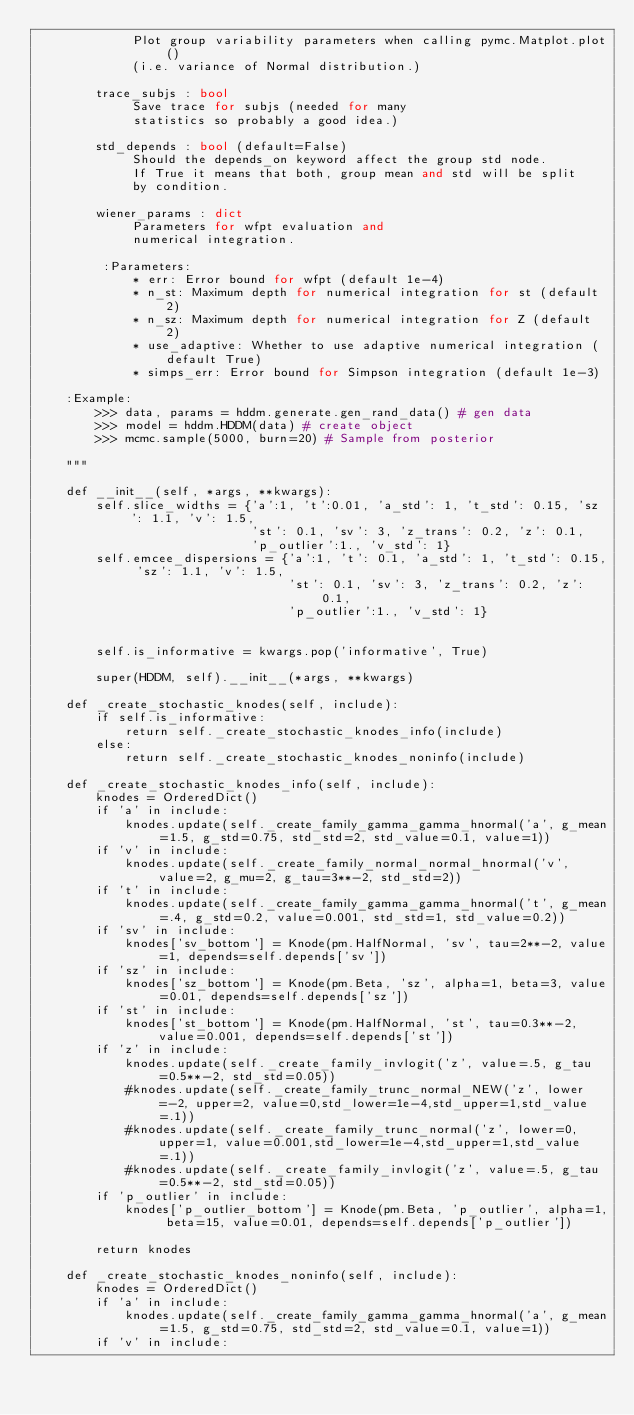<code> <loc_0><loc_0><loc_500><loc_500><_Python_>             Plot group variability parameters when calling pymc.Matplot.plot()
             (i.e. variance of Normal distribution.)

        trace_subjs : bool
             Save trace for subjs (needed for many
             statistics so probably a good idea.)

        std_depends : bool (default=False)
             Should the depends_on keyword affect the group std node.
             If True it means that both, group mean and std will be split
             by condition.

        wiener_params : dict
             Parameters for wfpt evaluation and
             numerical integration.

         :Parameters:
             * err: Error bound for wfpt (default 1e-4)
             * n_st: Maximum depth for numerical integration for st (default 2)
             * n_sz: Maximum depth for numerical integration for Z (default 2)
             * use_adaptive: Whether to use adaptive numerical integration (default True)
             * simps_err: Error bound for Simpson integration (default 1e-3)

    :Example:
        >>> data, params = hddm.generate.gen_rand_data() # gen data
        >>> model = hddm.HDDM(data) # create object
        >>> mcmc.sample(5000, burn=20) # Sample from posterior

    """

    def __init__(self, *args, **kwargs):
        self.slice_widths = {'a':1, 't':0.01, 'a_std': 1, 't_std': 0.15, 'sz': 1.1, 'v': 1.5,
                             'st': 0.1, 'sv': 3, 'z_trans': 0.2, 'z': 0.1,
                             'p_outlier':1., 'v_std': 1}
        self.emcee_dispersions = {'a':1, 't': 0.1, 'a_std': 1, 't_std': 0.15, 'sz': 1.1, 'v': 1.5,
                                  'st': 0.1, 'sv': 3, 'z_trans': 0.2, 'z': 0.1,
                                  'p_outlier':1., 'v_std': 1}


        self.is_informative = kwargs.pop('informative', True)

        super(HDDM, self).__init__(*args, **kwargs)

    def _create_stochastic_knodes(self, include):
        if self.is_informative:
            return self._create_stochastic_knodes_info(include)
        else:
            return self._create_stochastic_knodes_noninfo(include)

    def _create_stochastic_knodes_info(self, include):
        knodes = OrderedDict()
        if 'a' in include:
            knodes.update(self._create_family_gamma_gamma_hnormal('a', g_mean=1.5, g_std=0.75, std_std=2, std_value=0.1, value=1))
        if 'v' in include:
            knodes.update(self._create_family_normal_normal_hnormal('v', value=2, g_mu=2, g_tau=3**-2, std_std=2))
        if 't' in include:
            knodes.update(self._create_family_gamma_gamma_hnormal('t', g_mean=.4, g_std=0.2, value=0.001, std_std=1, std_value=0.2))
        if 'sv' in include:
            knodes['sv_bottom'] = Knode(pm.HalfNormal, 'sv', tau=2**-2, value=1, depends=self.depends['sv'])
        if 'sz' in include:
            knodes['sz_bottom'] = Knode(pm.Beta, 'sz', alpha=1, beta=3, value=0.01, depends=self.depends['sz'])
        if 'st' in include:
            knodes['st_bottom'] = Knode(pm.HalfNormal, 'st', tau=0.3**-2, value=0.001, depends=self.depends['st'])
        if 'z' in include:
            knodes.update(self._create_family_invlogit('z', value=.5, g_tau=0.5**-2, std_std=0.05))
            #knodes.update(self._create_family_trunc_normal_NEW('z', lower=-2, upper=2, value=0,std_lower=1e-4,std_upper=1,std_value=.1))
            #knodes.update(self._create_family_trunc_normal('z', lower=0, upper=1, value=0.001,std_lower=1e-4,std_upper=1,std_value=.1))
            #knodes.update(self._create_family_invlogit('z', value=.5, g_tau=0.5**-2, std_std=0.05))
        if 'p_outlier' in include:
            knodes['p_outlier_bottom'] = Knode(pm.Beta, 'p_outlier', alpha=1, beta=15, value=0.01, depends=self.depends['p_outlier'])

        return knodes

    def _create_stochastic_knodes_noninfo(self, include):
        knodes = OrderedDict()
        if 'a' in include:
            knodes.update(self._create_family_gamma_gamma_hnormal('a', g_mean=1.5, g_std=0.75, std_std=2, std_value=0.1, value=1))
        if 'v' in include:</code> 